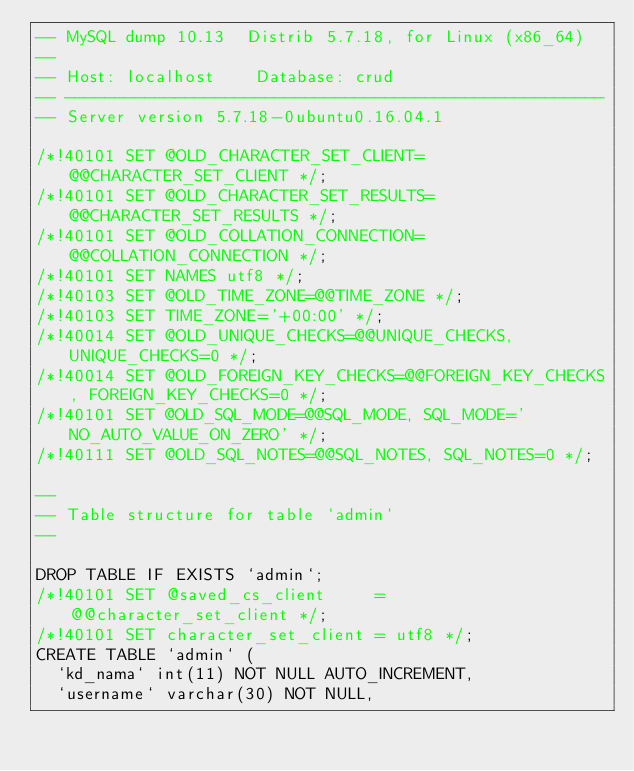<code> <loc_0><loc_0><loc_500><loc_500><_SQL_>-- MySQL dump 10.13  Distrib 5.7.18, for Linux (x86_64)
--
-- Host: localhost    Database: crud
-- ------------------------------------------------------
-- Server version	5.7.18-0ubuntu0.16.04.1

/*!40101 SET @OLD_CHARACTER_SET_CLIENT=@@CHARACTER_SET_CLIENT */;
/*!40101 SET @OLD_CHARACTER_SET_RESULTS=@@CHARACTER_SET_RESULTS */;
/*!40101 SET @OLD_COLLATION_CONNECTION=@@COLLATION_CONNECTION */;
/*!40101 SET NAMES utf8 */;
/*!40103 SET @OLD_TIME_ZONE=@@TIME_ZONE */;
/*!40103 SET TIME_ZONE='+00:00' */;
/*!40014 SET @OLD_UNIQUE_CHECKS=@@UNIQUE_CHECKS, UNIQUE_CHECKS=0 */;
/*!40014 SET @OLD_FOREIGN_KEY_CHECKS=@@FOREIGN_KEY_CHECKS, FOREIGN_KEY_CHECKS=0 */;
/*!40101 SET @OLD_SQL_MODE=@@SQL_MODE, SQL_MODE='NO_AUTO_VALUE_ON_ZERO' */;
/*!40111 SET @OLD_SQL_NOTES=@@SQL_NOTES, SQL_NOTES=0 */;

--
-- Table structure for table `admin`
--

DROP TABLE IF EXISTS `admin`;
/*!40101 SET @saved_cs_client     = @@character_set_client */;
/*!40101 SET character_set_client = utf8 */;
CREATE TABLE `admin` (
  `kd_nama` int(11) NOT NULL AUTO_INCREMENT,
  `username` varchar(30) NOT NULL,</code> 